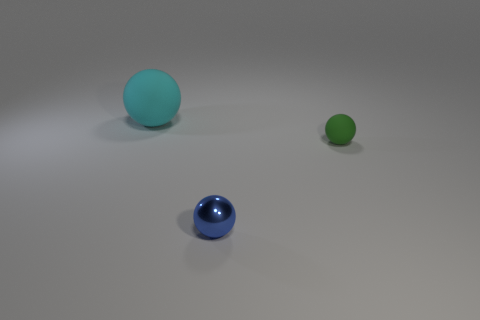How many shiny things are large purple cylinders or big objects?
Give a very brief answer. 0. There is a thing that is in front of the matte thing in front of the big cyan sphere; what is its shape?
Keep it short and to the point. Sphere. Are there fewer tiny metal objects to the left of the green rubber thing than big brown shiny blocks?
Offer a very short reply. No. There is a rubber sphere that is right of the large cyan object; what is its size?
Your answer should be compact. Small. What is the color of the ball that is the same size as the green rubber thing?
Give a very brief answer. Blue. Is there another tiny object that has the same color as the shiny thing?
Ensure brevity in your answer.  No. Is the number of large objects right of the tiny green rubber object less than the number of large cyan rubber things that are in front of the tiny metallic ball?
Keep it short and to the point. No. What is the material of the sphere that is both left of the green rubber sphere and in front of the large ball?
Make the answer very short. Metal. Is the shape of the cyan object the same as the small thing that is in front of the small rubber object?
Your answer should be compact. Yes. What number of other things are the same size as the cyan matte thing?
Offer a very short reply. 0. 